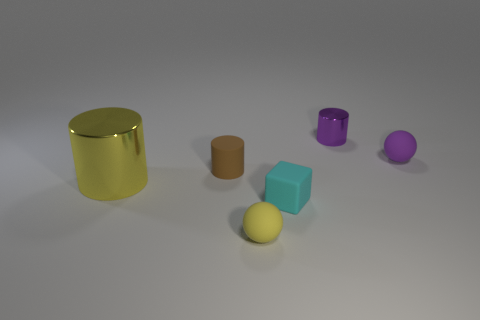Is there anything else that is the same size as the yellow cylinder?
Offer a very short reply. No. The rubber object that is the same color as the big cylinder is what shape?
Keep it short and to the point. Sphere. The other metal thing that is the same shape as the big yellow metallic thing is what color?
Your response must be concise. Purple. Is the yellow thing that is left of the small yellow thing made of the same material as the small yellow thing?
Your answer should be very brief. No. What number of big things are either purple metal cylinders or yellow rubber balls?
Offer a terse response. 0. The cyan rubber object is what size?
Your response must be concise. Small. There is a yellow metal thing; is its size the same as the sphere that is in front of the yellow cylinder?
Offer a very short reply. No. How many yellow objects are either large things or shiny things?
Give a very brief answer. 1. How many large brown shiny cylinders are there?
Keep it short and to the point. 0. What size is the sphere behind the small cyan rubber thing?
Provide a short and direct response. Small. 